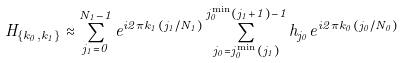Convert formula to latex. <formula><loc_0><loc_0><loc_500><loc_500>H _ { \{ k _ { 0 } , k _ { 1 } \} } \approx \sum _ { j _ { 1 } = 0 } ^ { N _ { 1 } - 1 } e ^ { i 2 \pi k _ { 1 } ( j _ { 1 } / N _ { 1 } ) } \sum _ { j _ { 0 } = j _ { 0 } ^ { \min } ( j _ { 1 } ) } ^ { j _ { 0 } ^ { \min } ( j _ { 1 } + 1 ) - 1 } h _ { j _ { 0 } } e ^ { i 2 \pi k _ { 0 } ( j _ { 0 } / N _ { 0 } ) }</formula> 